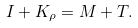<formula> <loc_0><loc_0><loc_500><loc_500>I + K _ { \rho } = M + T .</formula> 